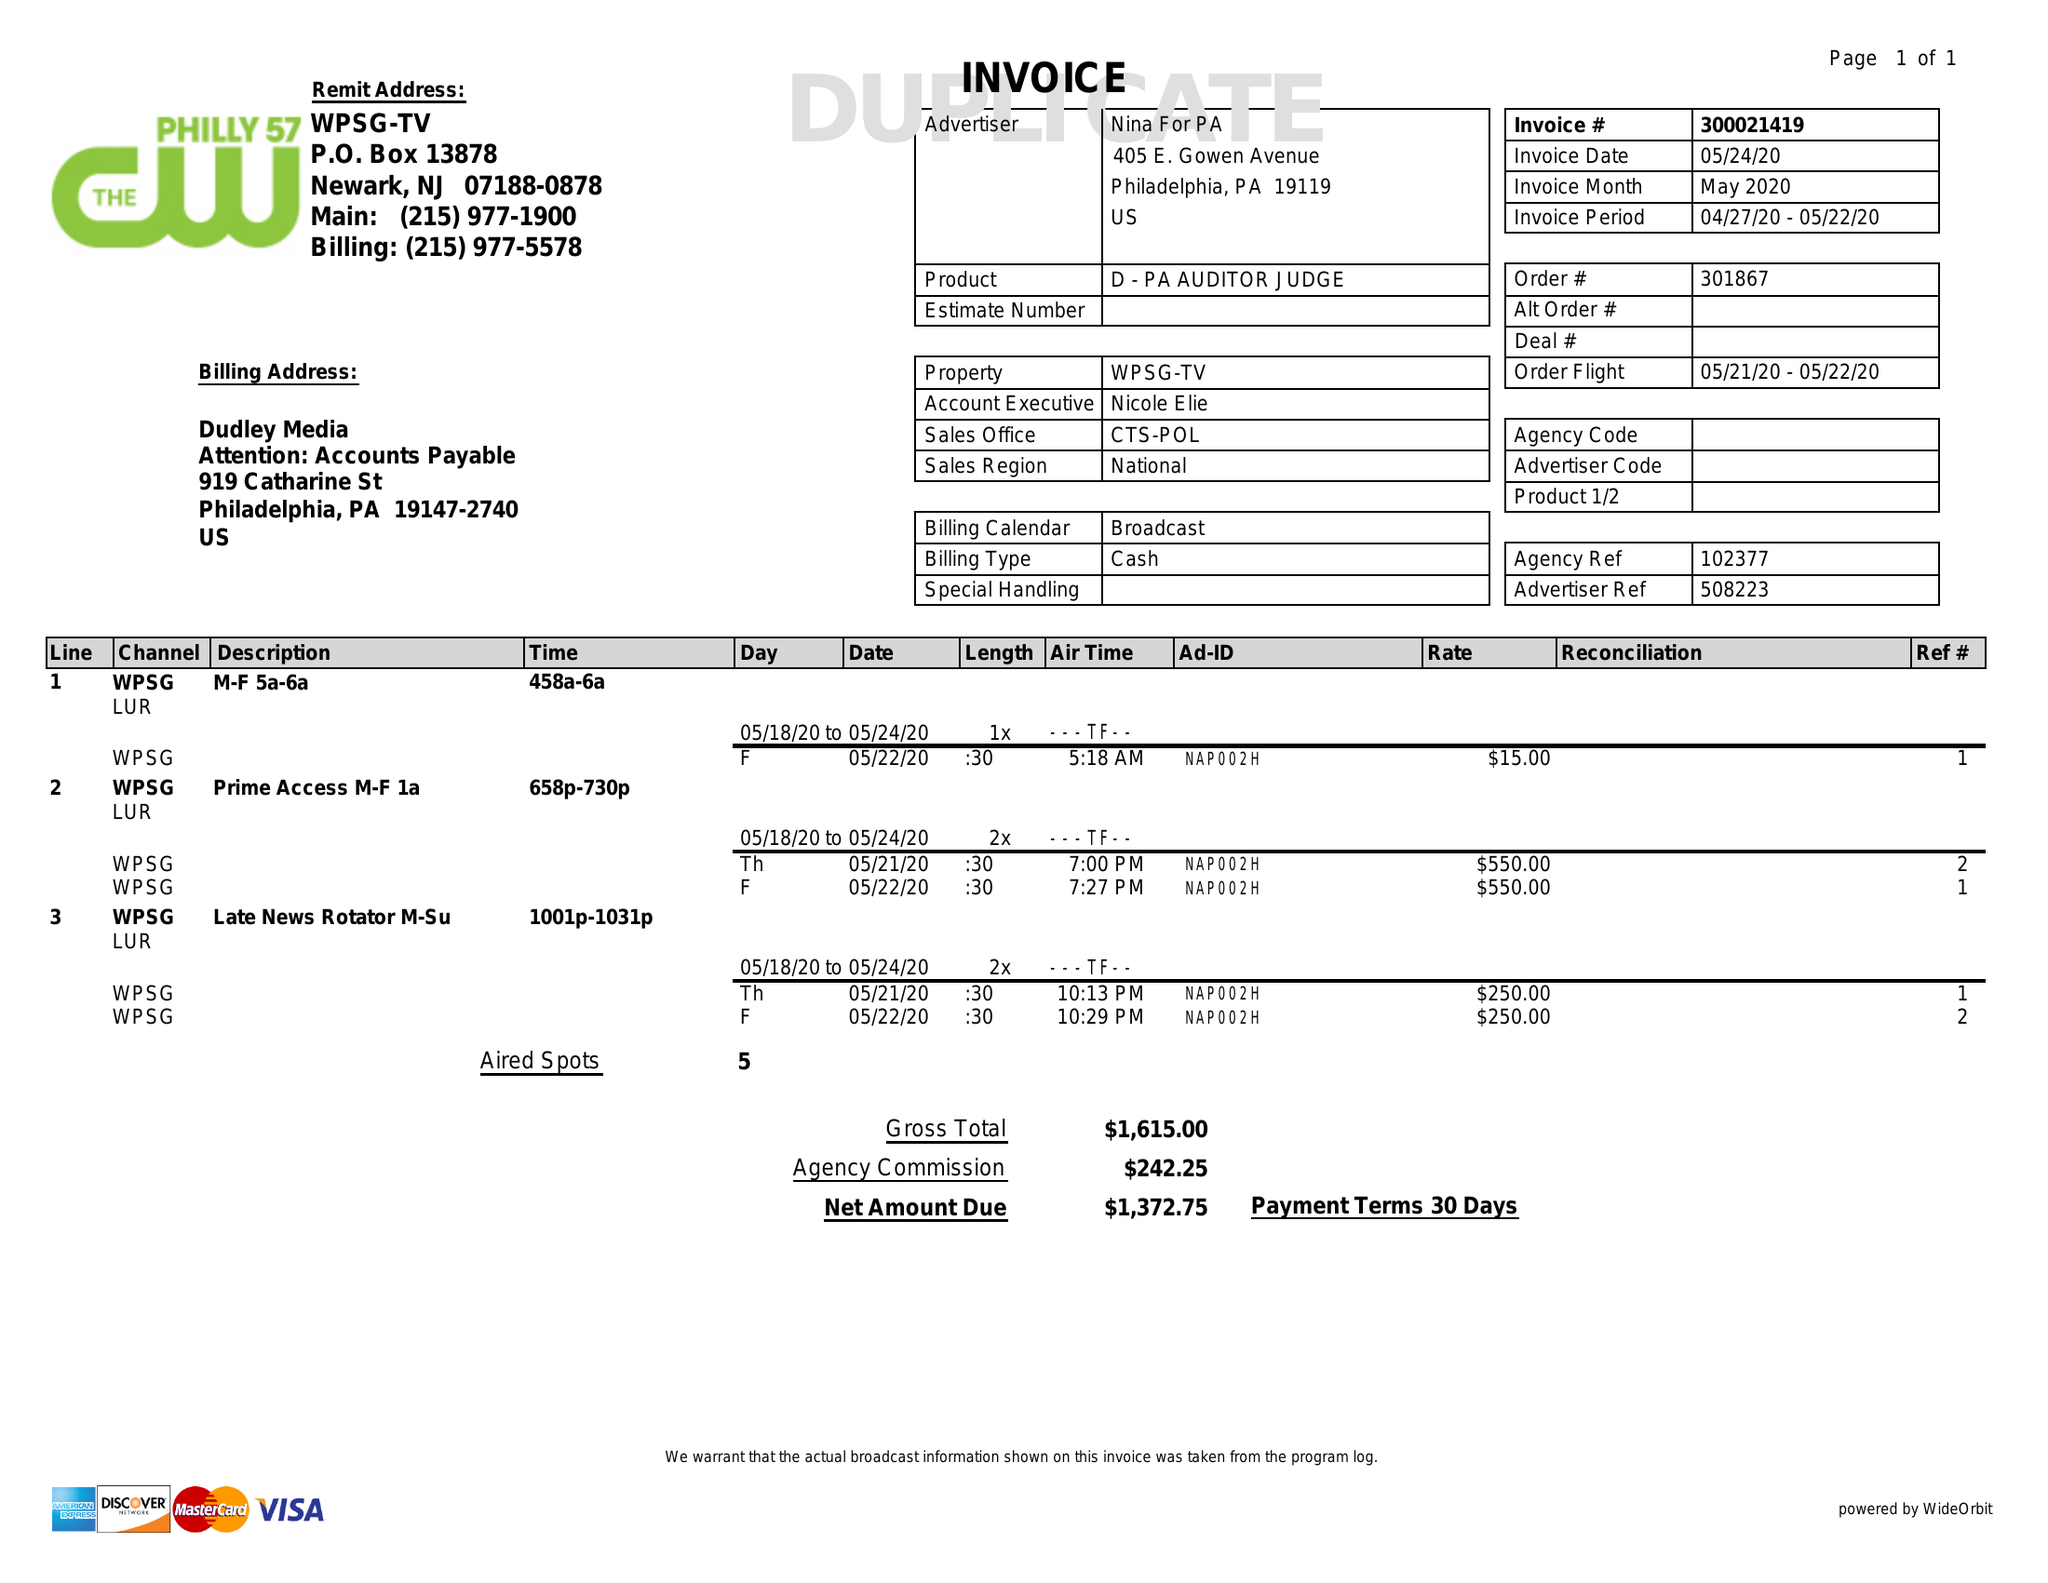What is the value for the gross_amount?
Answer the question using a single word or phrase. 1615.00 